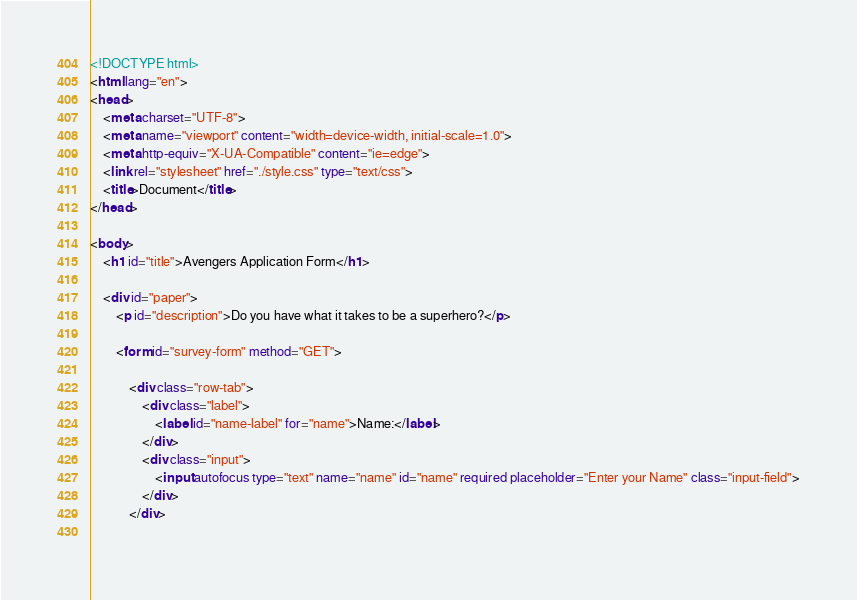Convert code to text. <code><loc_0><loc_0><loc_500><loc_500><_HTML_><!DOCTYPE html>
<html lang="en">
<head>
    <meta charset="UTF-8">
    <meta name="viewport" content="width=device-width, initial-scale=1.0">
    <meta http-equiv="X-UA-Compatible" content="ie=edge">
    <link rel="stylesheet" href="./style.css" type="text/css">
    <title>Document</title>
</head>

<body>
    <h1 id="title">Avengers Application Form</h1>

    <div id="paper">
        <p id="description">Do you have what it takes to be a superhero?</p>

        <form id="survey-form" method="GET">

            <div class="row-tab">  
                <div class="label">  
                    <label id="name-label" for="name">Name:</label>
                </div>
                <div class="input">
                    <input autofocus type="text" name="name" id="name" required placeholder="Enter your Name" class="input-field">
                </div>
            </div>    
    </code> 